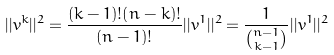<formula> <loc_0><loc_0><loc_500><loc_500>| | v ^ { k } | | ^ { 2 } = \frac { ( k - 1 ) ! ( n - k ) ! } { ( n - 1 ) ! } | | v ^ { 1 } | | ^ { 2 } = \frac { 1 } { \binom { n - 1 } { k - 1 } } | | v ^ { 1 } | | ^ { 2 }</formula> 